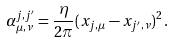Convert formula to latex. <formula><loc_0><loc_0><loc_500><loc_500>\alpha _ { \mu , \nu } ^ { j , j ^ { \prime } } = \frac { \eta } { 2 \pi } ( x _ { j , \mu } - x _ { j ^ { \prime } , \nu } ) ^ { 2 } \, .</formula> 